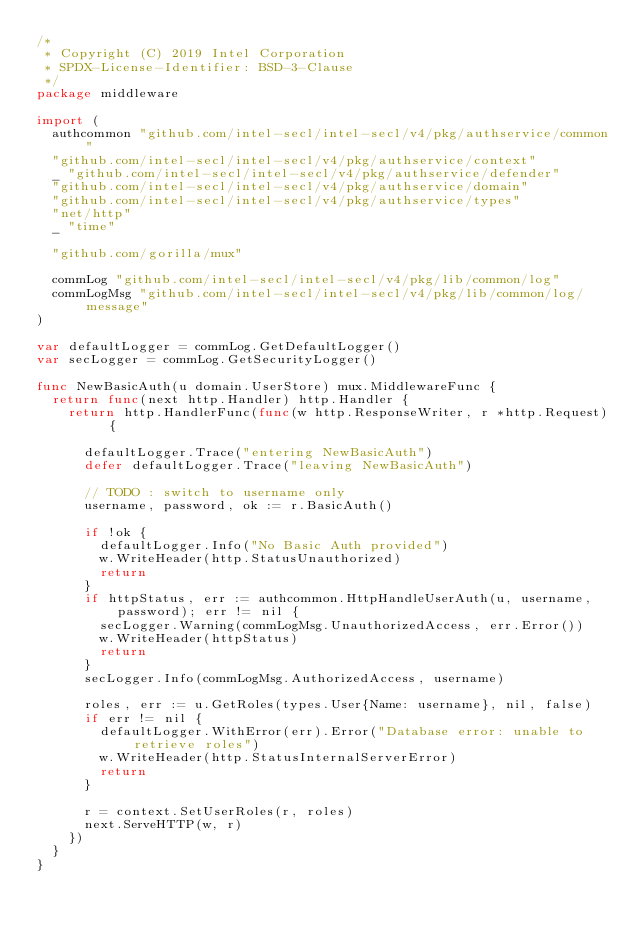Convert code to text. <code><loc_0><loc_0><loc_500><loc_500><_Go_>/*
 * Copyright (C) 2019 Intel Corporation
 * SPDX-License-Identifier: BSD-3-Clause
 */
package middleware

import (
	authcommon "github.com/intel-secl/intel-secl/v4/pkg/authservice/common"
	"github.com/intel-secl/intel-secl/v4/pkg/authservice/context"
	_ "github.com/intel-secl/intel-secl/v4/pkg/authservice/defender"
	"github.com/intel-secl/intel-secl/v4/pkg/authservice/domain"
	"github.com/intel-secl/intel-secl/v4/pkg/authservice/types"
	"net/http"
	_ "time"

	"github.com/gorilla/mux"

	commLog "github.com/intel-secl/intel-secl/v4/pkg/lib/common/log"
	commLogMsg "github.com/intel-secl/intel-secl/v4/pkg/lib/common/log/message"
)

var defaultLogger = commLog.GetDefaultLogger()
var secLogger = commLog.GetSecurityLogger()

func NewBasicAuth(u domain.UserStore) mux.MiddlewareFunc {
	return func(next http.Handler) http.Handler {
		return http.HandlerFunc(func(w http.ResponseWriter, r *http.Request) {

			defaultLogger.Trace("entering NewBasicAuth")
			defer defaultLogger.Trace("leaving NewBasicAuth")

			// TODO : switch to username only
			username, password, ok := r.BasicAuth()

			if !ok {
				defaultLogger.Info("No Basic Auth provided")
				w.WriteHeader(http.StatusUnauthorized)
				return
			}
			if httpStatus, err := authcommon.HttpHandleUserAuth(u, username, password); err != nil {
				secLogger.Warning(commLogMsg.UnauthorizedAccess, err.Error())
				w.WriteHeader(httpStatus)
				return
			}
			secLogger.Info(commLogMsg.AuthorizedAccess, username)

			roles, err := u.GetRoles(types.User{Name: username}, nil, false)
			if err != nil {
				defaultLogger.WithError(err).Error("Database error: unable to retrieve roles")
				w.WriteHeader(http.StatusInternalServerError)
				return
			}

			r = context.SetUserRoles(r, roles)
			next.ServeHTTP(w, r)
		})
	}
}
</code> 